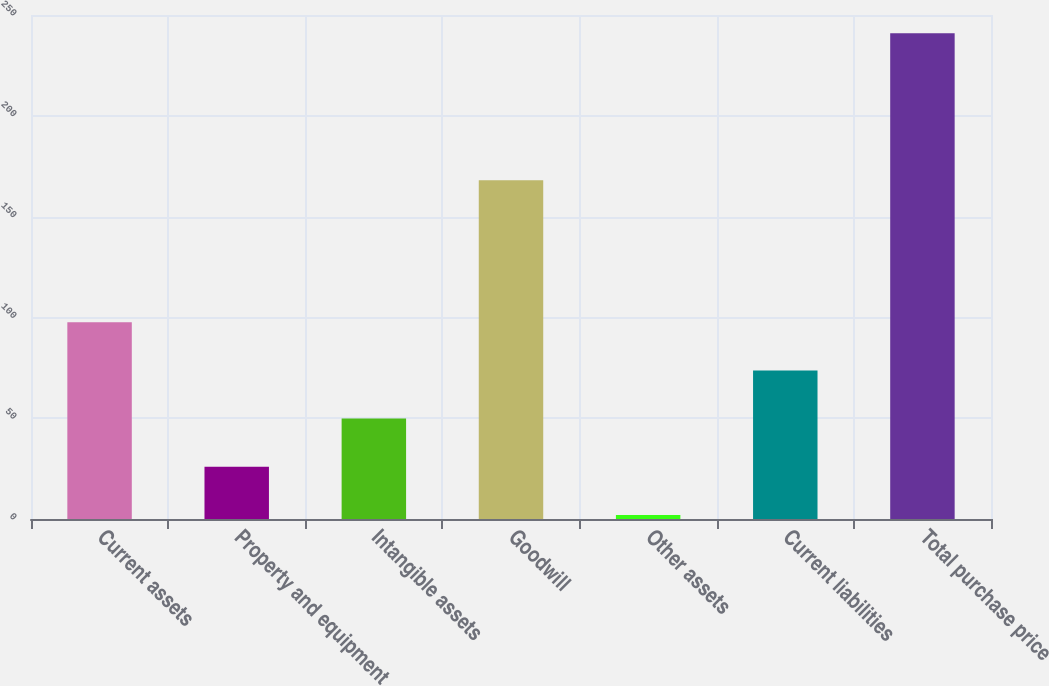Convert chart. <chart><loc_0><loc_0><loc_500><loc_500><bar_chart><fcel>Current assets<fcel>Property and equipment<fcel>Intangible assets<fcel>Goodwill<fcel>Other assets<fcel>Current liabilities<fcel>Total purchase price<nl><fcel>97.6<fcel>25.9<fcel>49.8<fcel>168<fcel>2<fcel>73.7<fcel>241<nl></chart> 